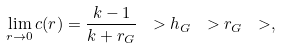Convert formula to latex. <formula><loc_0><loc_0><loc_500><loc_500>\lim _ { r \rightarrow 0 } c ( r ) = \frac { k - 1 } { k + r _ { G } } \ > h _ { G } \ > r _ { G } \ > ,</formula> 